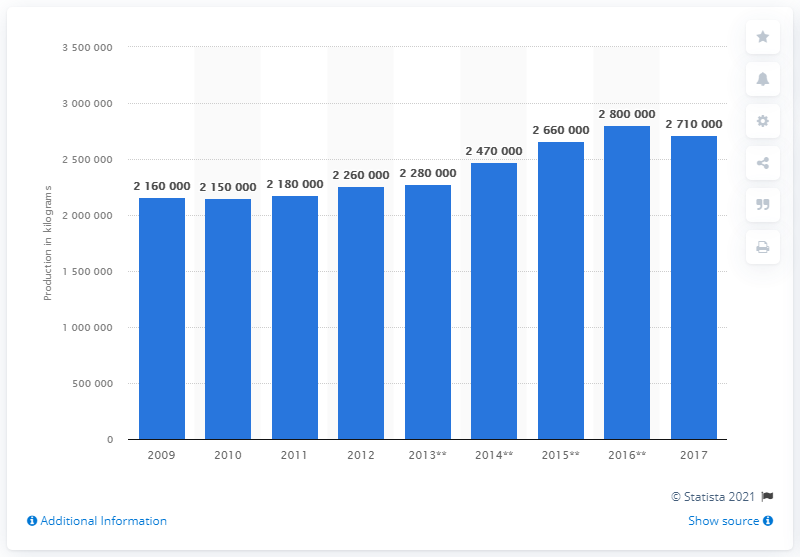Mention a couple of crucial points in this snapshot. In 2017, the estimated world refinery production of selenium was approximately 2710000 units. In 2017, the estimated world refinery production of selenium was approximately 2710000 metric tons. 